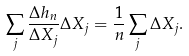Convert formula to latex. <formula><loc_0><loc_0><loc_500><loc_500>\sum _ { j } \frac { \Delta h _ { n } } { \Delta X _ { j } } \Delta X _ { j } = \frac { 1 } { n } \sum _ { j } \Delta X _ { j } .</formula> 